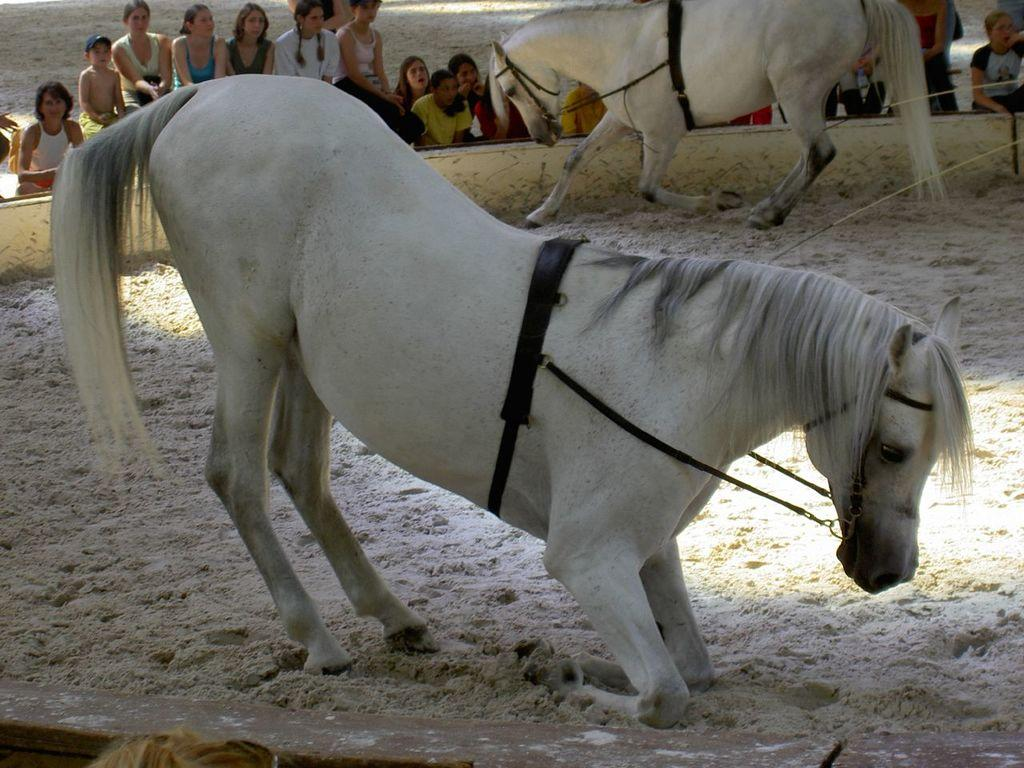How many horses are in the image? There are two horses in the image. What type of surface are the horses on? The horses are on a sand surface. Can you describe the environment around the horses? There are many people around the horses. What color are the tomatoes growing in the cellar in the image? There are no tomatoes or cellar present in the image; it features two horses on a sand surface with many people around them. 